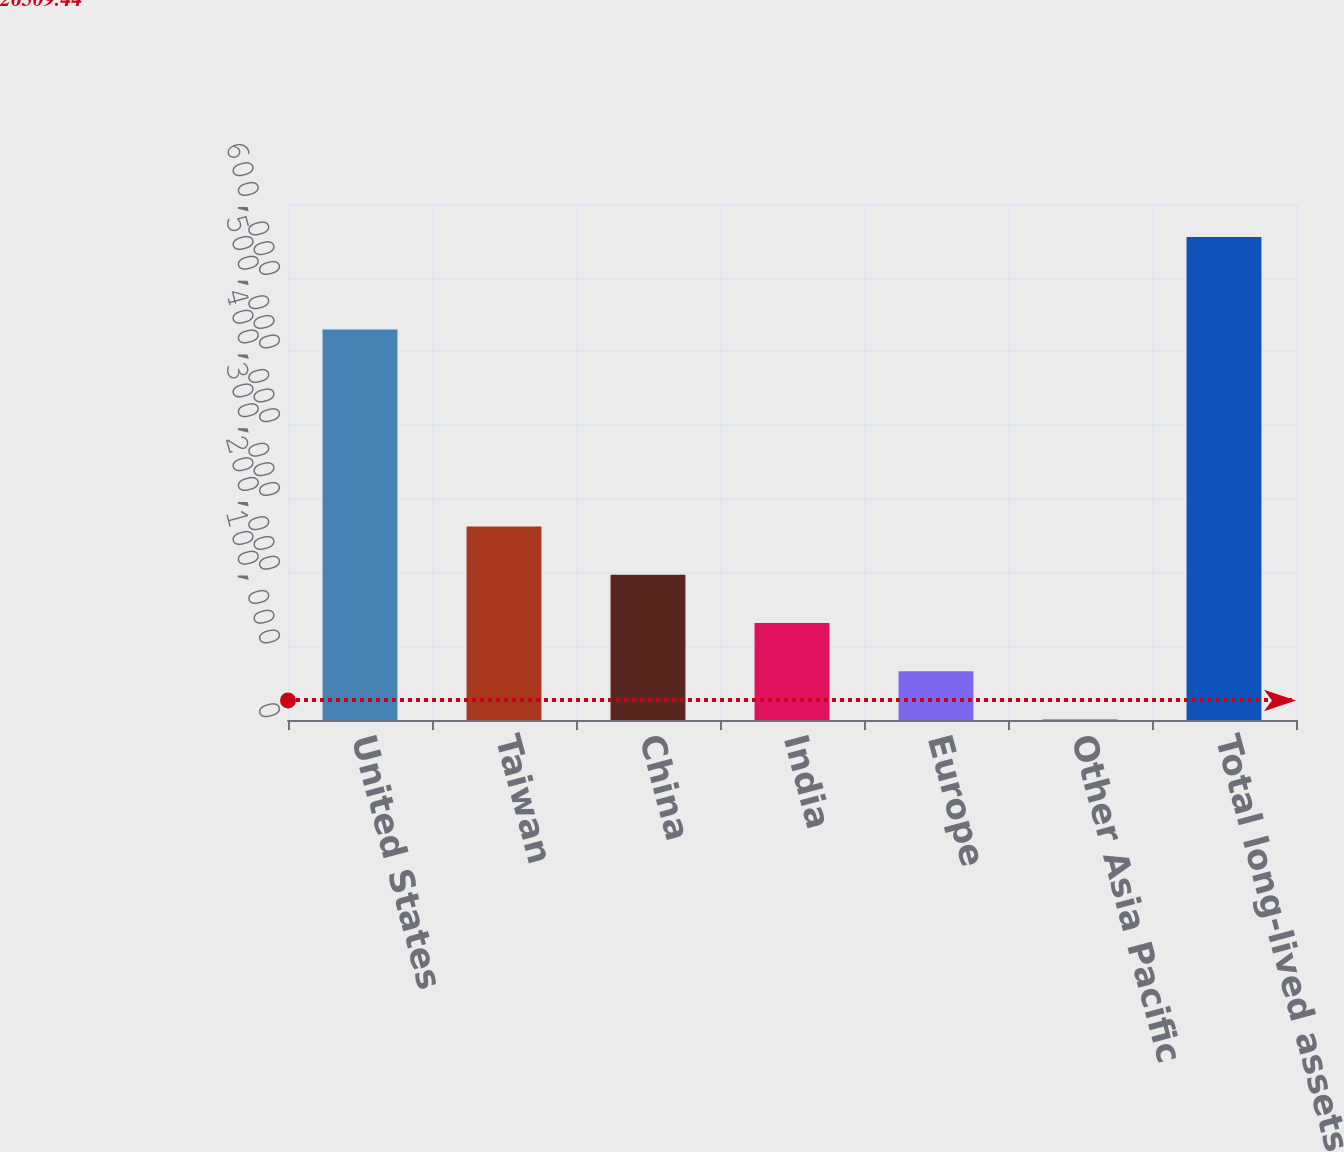<chart> <loc_0><loc_0><loc_500><loc_500><bar_chart><fcel>United States<fcel>Taiwan<fcel>China<fcel>India<fcel>Europe<fcel>Other Asia Pacific<fcel>Total long-lived assets<nl><fcel>529797<fcel>262585<fcel>197135<fcel>131686<fcel>66236.4<fcel>787<fcel>655281<nl></chart> 